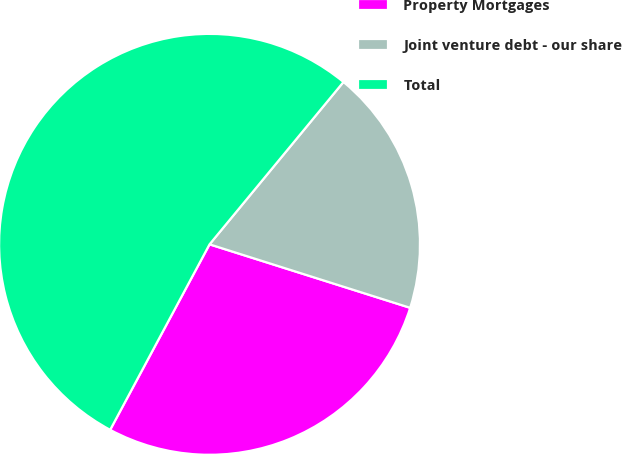Convert chart to OTSL. <chart><loc_0><loc_0><loc_500><loc_500><pie_chart><fcel>Property Mortgages<fcel>Joint venture debt - our share<fcel>Total<nl><fcel>27.95%<fcel>18.9%<fcel>53.15%<nl></chart> 